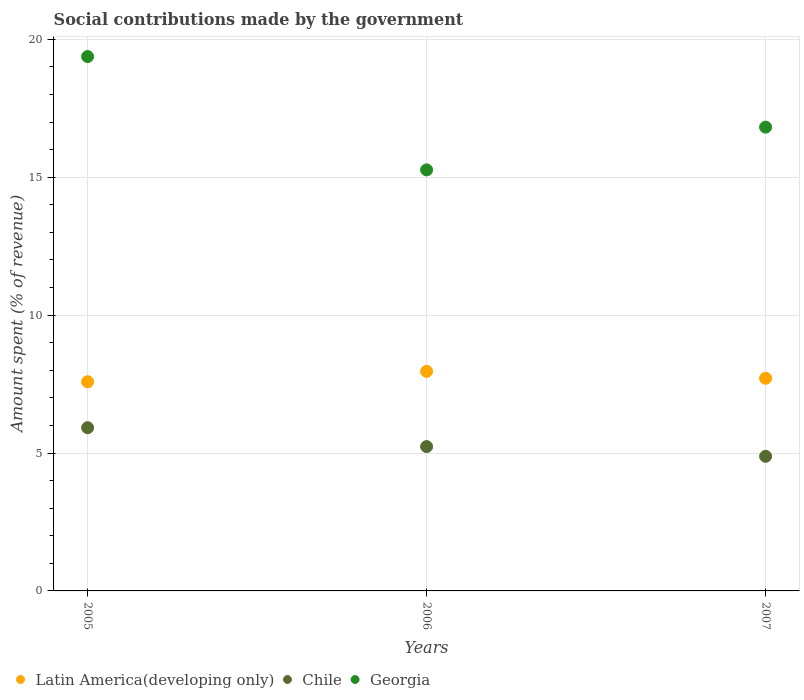How many different coloured dotlines are there?
Your response must be concise. 3. Is the number of dotlines equal to the number of legend labels?
Your answer should be compact. Yes. What is the amount spent (in %) on social contributions in Latin America(developing only) in 2006?
Your response must be concise. 7.96. Across all years, what is the maximum amount spent (in %) on social contributions in Georgia?
Offer a very short reply. 19.38. Across all years, what is the minimum amount spent (in %) on social contributions in Latin America(developing only)?
Your answer should be very brief. 7.58. In which year was the amount spent (in %) on social contributions in Latin America(developing only) maximum?
Provide a short and direct response. 2006. What is the total amount spent (in %) on social contributions in Latin America(developing only) in the graph?
Your response must be concise. 23.26. What is the difference between the amount spent (in %) on social contributions in Latin America(developing only) in 2006 and that in 2007?
Provide a succinct answer. 0.25. What is the difference between the amount spent (in %) on social contributions in Chile in 2006 and the amount spent (in %) on social contributions in Latin America(developing only) in 2005?
Offer a terse response. -2.35. What is the average amount spent (in %) on social contributions in Chile per year?
Your response must be concise. 5.34. In the year 2006, what is the difference between the amount spent (in %) on social contributions in Georgia and amount spent (in %) on social contributions in Chile?
Ensure brevity in your answer.  10.03. What is the ratio of the amount spent (in %) on social contributions in Latin America(developing only) in 2005 to that in 2007?
Your answer should be very brief. 0.98. Is the amount spent (in %) on social contributions in Georgia in 2005 less than that in 2007?
Your answer should be compact. No. Is the difference between the amount spent (in %) on social contributions in Georgia in 2005 and 2007 greater than the difference between the amount spent (in %) on social contributions in Chile in 2005 and 2007?
Keep it short and to the point. Yes. What is the difference between the highest and the second highest amount spent (in %) on social contributions in Latin America(developing only)?
Provide a short and direct response. 0.25. What is the difference between the highest and the lowest amount spent (in %) on social contributions in Georgia?
Provide a succinct answer. 4.11. In how many years, is the amount spent (in %) on social contributions in Latin America(developing only) greater than the average amount spent (in %) on social contributions in Latin America(developing only) taken over all years?
Make the answer very short. 1. Is the sum of the amount spent (in %) on social contributions in Latin America(developing only) in 2005 and 2007 greater than the maximum amount spent (in %) on social contributions in Georgia across all years?
Provide a short and direct response. No. Is it the case that in every year, the sum of the amount spent (in %) on social contributions in Chile and amount spent (in %) on social contributions in Georgia  is greater than the amount spent (in %) on social contributions in Latin America(developing only)?
Your response must be concise. Yes. Is the amount spent (in %) on social contributions in Chile strictly greater than the amount spent (in %) on social contributions in Georgia over the years?
Your response must be concise. No. How many dotlines are there?
Ensure brevity in your answer.  3. What is the difference between two consecutive major ticks on the Y-axis?
Your response must be concise. 5. Does the graph contain any zero values?
Ensure brevity in your answer.  No. How many legend labels are there?
Offer a terse response. 3. What is the title of the graph?
Your response must be concise. Social contributions made by the government. What is the label or title of the X-axis?
Provide a short and direct response. Years. What is the label or title of the Y-axis?
Keep it short and to the point. Amount spent (% of revenue). What is the Amount spent (% of revenue) in Latin America(developing only) in 2005?
Give a very brief answer. 7.58. What is the Amount spent (% of revenue) of Chile in 2005?
Provide a succinct answer. 5.92. What is the Amount spent (% of revenue) in Georgia in 2005?
Give a very brief answer. 19.38. What is the Amount spent (% of revenue) of Latin America(developing only) in 2006?
Provide a succinct answer. 7.96. What is the Amount spent (% of revenue) in Chile in 2006?
Make the answer very short. 5.23. What is the Amount spent (% of revenue) in Georgia in 2006?
Provide a succinct answer. 15.27. What is the Amount spent (% of revenue) of Latin America(developing only) in 2007?
Offer a terse response. 7.71. What is the Amount spent (% of revenue) in Chile in 2007?
Provide a succinct answer. 4.88. What is the Amount spent (% of revenue) in Georgia in 2007?
Give a very brief answer. 16.82. Across all years, what is the maximum Amount spent (% of revenue) of Latin America(developing only)?
Offer a very short reply. 7.96. Across all years, what is the maximum Amount spent (% of revenue) in Chile?
Your answer should be very brief. 5.92. Across all years, what is the maximum Amount spent (% of revenue) of Georgia?
Your answer should be very brief. 19.38. Across all years, what is the minimum Amount spent (% of revenue) in Latin America(developing only)?
Offer a very short reply. 7.58. Across all years, what is the minimum Amount spent (% of revenue) of Chile?
Make the answer very short. 4.88. Across all years, what is the minimum Amount spent (% of revenue) in Georgia?
Offer a very short reply. 15.27. What is the total Amount spent (% of revenue) in Latin America(developing only) in the graph?
Offer a very short reply. 23.26. What is the total Amount spent (% of revenue) of Chile in the graph?
Make the answer very short. 16.03. What is the total Amount spent (% of revenue) in Georgia in the graph?
Keep it short and to the point. 51.46. What is the difference between the Amount spent (% of revenue) in Latin America(developing only) in 2005 and that in 2006?
Ensure brevity in your answer.  -0.38. What is the difference between the Amount spent (% of revenue) in Chile in 2005 and that in 2006?
Your response must be concise. 0.68. What is the difference between the Amount spent (% of revenue) of Georgia in 2005 and that in 2006?
Keep it short and to the point. 4.11. What is the difference between the Amount spent (% of revenue) in Latin America(developing only) in 2005 and that in 2007?
Provide a short and direct response. -0.13. What is the difference between the Amount spent (% of revenue) in Chile in 2005 and that in 2007?
Your answer should be compact. 1.04. What is the difference between the Amount spent (% of revenue) of Georgia in 2005 and that in 2007?
Make the answer very short. 2.56. What is the difference between the Amount spent (% of revenue) in Latin America(developing only) in 2006 and that in 2007?
Your answer should be compact. 0.25. What is the difference between the Amount spent (% of revenue) of Chile in 2006 and that in 2007?
Provide a short and direct response. 0.35. What is the difference between the Amount spent (% of revenue) of Georgia in 2006 and that in 2007?
Offer a very short reply. -1.55. What is the difference between the Amount spent (% of revenue) of Latin America(developing only) in 2005 and the Amount spent (% of revenue) of Chile in 2006?
Your answer should be compact. 2.35. What is the difference between the Amount spent (% of revenue) in Latin America(developing only) in 2005 and the Amount spent (% of revenue) in Georgia in 2006?
Your answer should be very brief. -7.68. What is the difference between the Amount spent (% of revenue) in Chile in 2005 and the Amount spent (% of revenue) in Georgia in 2006?
Provide a succinct answer. -9.35. What is the difference between the Amount spent (% of revenue) of Latin America(developing only) in 2005 and the Amount spent (% of revenue) of Chile in 2007?
Your answer should be very brief. 2.7. What is the difference between the Amount spent (% of revenue) of Latin America(developing only) in 2005 and the Amount spent (% of revenue) of Georgia in 2007?
Give a very brief answer. -9.23. What is the difference between the Amount spent (% of revenue) of Chile in 2005 and the Amount spent (% of revenue) of Georgia in 2007?
Make the answer very short. -10.9. What is the difference between the Amount spent (% of revenue) in Latin America(developing only) in 2006 and the Amount spent (% of revenue) in Chile in 2007?
Ensure brevity in your answer.  3.08. What is the difference between the Amount spent (% of revenue) in Latin America(developing only) in 2006 and the Amount spent (% of revenue) in Georgia in 2007?
Offer a terse response. -8.86. What is the difference between the Amount spent (% of revenue) of Chile in 2006 and the Amount spent (% of revenue) of Georgia in 2007?
Provide a succinct answer. -11.58. What is the average Amount spent (% of revenue) in Latin America(developing only) per year?
Make the answer very short. 7.75. What is the average Amount spent (% of revenue) in Chile per year?
Offer a terse response. 5.34. What is the average Amount spent (% of revenue) of Georgia per year?
Your answer should be very brief. 17.15. In the year 2005, what is the difference between the Amount spent (% of revenue) in Latin America(developing only) and Amount spent (% of revenue) in Chile?
Your response must be concise. 1.67. In the year 2005, what is the difference between the Amount spent (% of revenue) in Latin America(developing only) and Amount spent (% of revenue) in Georgia?
Your response must be concise. -11.79. In the year 2005, what is the difference between the Amount spent (% of revenue) of Chile and Amount spent (% of revenue) of Georgia?
Keep it short and to the point. -13.46. In the year 2006, what is the difference between the Amount spent (% of revenue) in Latin America(developing only) and Amount spent (% of revenue) in Chile?
Make the answer very short. 2.73. In the year 2006, what is the difference between the Amount spent (% of revenue) of Latin America(developing only) and Amount spent (% of revenue) of Georgia?
Provide a succinct answer. -7.31. In the year 2006, what is the difference between the Amount spent (% of revenue) in Chile and Amount spent (% of revenue) in Georgia?
Provide a succinct answer. -10.03. In the year 2007, what is the difference between the Amount spent (% of revenue) of Latin America(developing only) and Amount spent (% of revenue) of Chile?
Provide a succinct answer. 2.83. In the year 2007, what is the difference between the Amount spent (% of revenue) of Latin America(developing only) and Amount spent (% of revenue) of Georgia?
Ensure brevity in your answer.  -9.11. In the year 2007, what is the difference between the Amount spent (% of revenue) in Chile and Amount spent (% of revenue) in Georgia?
Keep it short and to the point. -11.94. What is the ratio of the Amount spent (% of revenue) in Latin America(developing only) in 2005 to that in 2006?
Offer a terse response. 0.95. What is the ratio of the Amount spent (% of revenue) of Chile in 2005 to that in 2006?
Ensure brevity in your answer.  1.13. What is the ratio of the Amount spent (% of revenue) in Georgia in 2005 to that in 2006?
Offer a very short reply. 1.27. What is the ratio of the Amount spent (% of revenue) of Latin America(developing only) in 2005 to that in 2007?
Your response must be concise. 0.98. What is the ratio of the Amount spent (% of revenue) of Chile in 2005 to that in 2007?
Provide a short and direct response. 1.21. What is the ratio of the Amount spent (% of revenue) of Georgia in 2005 to that in 2007?
Your response must be concise. 1.15. What is the ratio of the Amount spent (% of revenue) of Latin America(developing only) in 2006 to that in 2007?
Make the answer very short. 1.03. What is the ratio of the Amount spent (% of revenue) of Chile in 2006 to that in 2007?
Make the answer very short. 1.07. What is the ratio of the Amount spent (% of revenue) of Georgia in 2006 to that in 2007?
Keep it short and to the point. 0.91. What is the difference between the highest and the second highest Amount spent (% of revenue) in Latin America(developing only)?
Offer a terse response. 0.25. What is the difference between the highest and the second highest Amount spent (% of revenue) of Chile?
Make the answer very short. 0.68. What is the difference between the highest and the second highest Amount spent (% of revenue) of Georgia?
Provide a succinct answer. 2.56. What is the difference between the highest and the lowest Amount spent (% of revenue) in Latin America(developing only)?
Keep it short and to the point. 0.38. What is the difference between the highest and the lowest Amount spent (% of revenue) in Chile?
Offer a terse response. 1.04. What is the difference between the highest and the lowest Amount spent (% of revenue) of Georgia?
Your response must be concise. 4.11. 